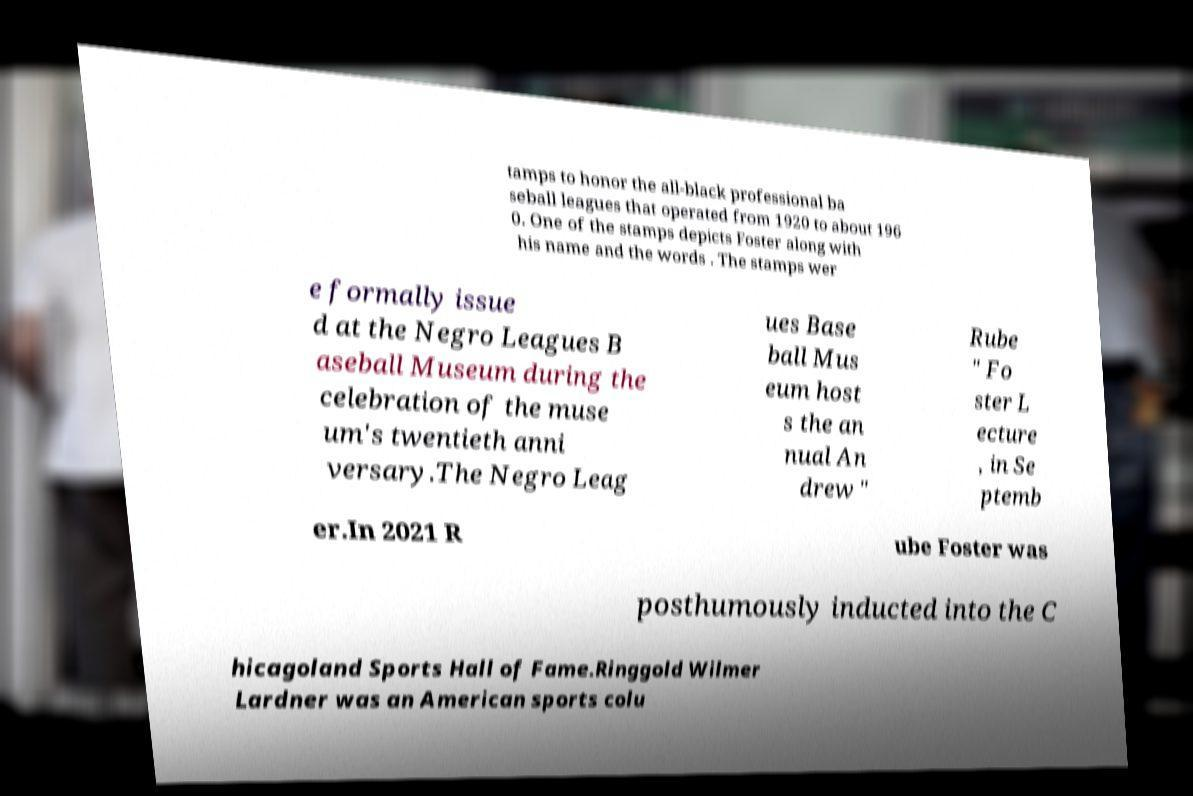Could you assist in decoding the text presented in this image and type it out clearly? tamps to honor the all-black professional ba seball leagues that operated from 1920 to about 196 0. One of the stamps depicts Foster along with his name and the words . The stamps wer e formally issue d at the Negro Leagues B aseball Museum during the celebration of the muse um's twentieth anni versary.The Negro Leag ues Base ball Mus eum host s the an nual An drew " Rube " Fo ster L ecture , in Se ptemb er.In 2021 R ube Foster was posthumously inducted into the C hicagoland Sports Hall of Fame.Ringgold Wilmer Lardner was an American sports colu 